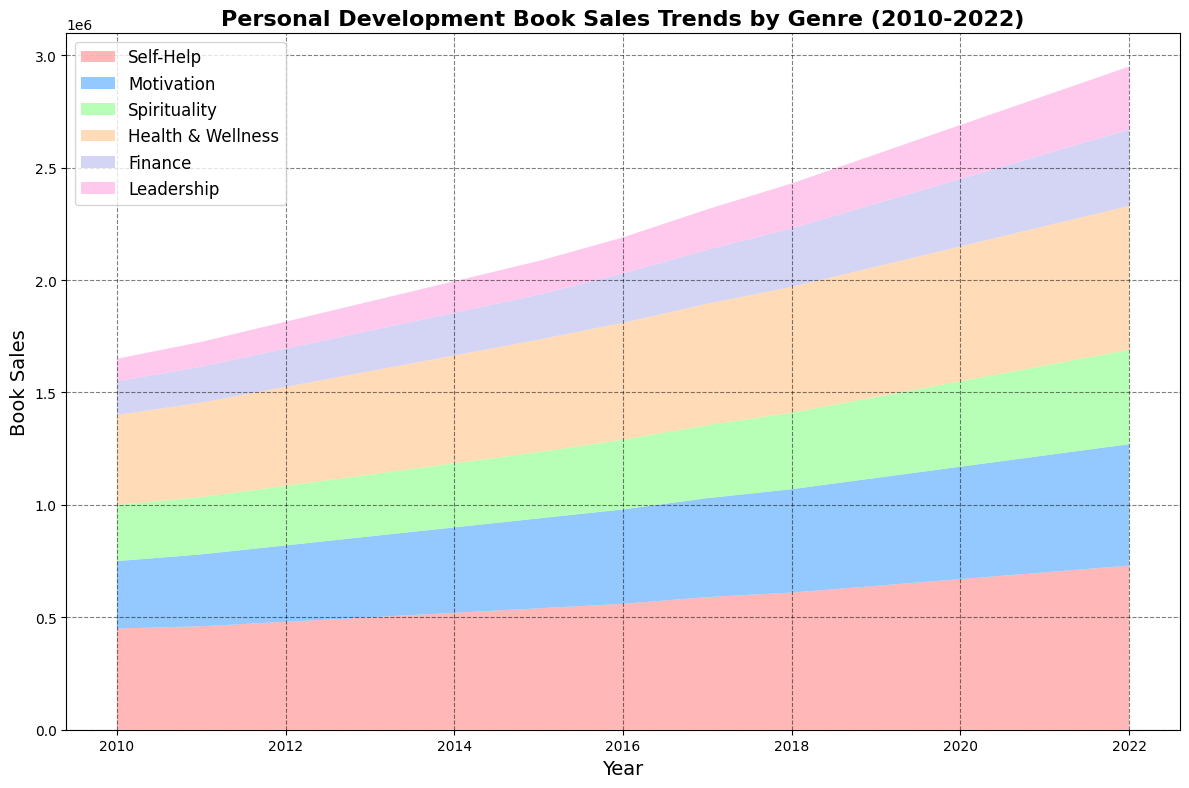what's the total sales for Self-Help books in 2013? In the year 2013, the Self-Help genre reached sales of 500,000 units.
Answer: 500,000 which genre had the highest sales in 2022? By observing the chart, it is evident that the Self-Help genre had the highest sales in the year 2022.
Answer: Self-Help compare the sales trends of Motivation and Leadership genres in 2015. Which one had higher sales? Checking the sales in 2015, the Motivation genre had sales of 400,000 while the Leadership genre had sales of 150,000. Therefore, Motivation had higher sales.
Answer: Motivation in which year did Finance sales reach 260,000 units? Reviewing the chart, Finance sales reached 260,000 units in 2018.
Answer: 2018 how much did Health & Wellness sales increase from 2010 to 2022? In 2010, Health & Wellness sales were 400,000 units, and in 2022 they were 640,000 units. The increase is 640,000 - 400,000 = 240,000 units.
Answer: 240,000 what's the combined sales for Spirituality and Finance genres in 2020? In 2020, Spirituality sales were 380,000 and Finance sales were 300,000. Combined, they add up to 380,000 + 300,000 = 680,000 units.
Answer: 680,000 which year saw Motivation book sales surpass Leadership book sales by the highest margin? The year with the greatest margin is 2022, where Motivation sales were 540,000, and Leadership sales were 280,000. The margin is 540,000 - 280,000 = 260,000 units.
Answer: 2022 what visual color represents the Health & Wellness genre? By observing the area chart, the Health & Wellness genre is depicted in green color.
Answer: green calculate the average sales of Self-Help books from 2010 to 2022. The sum of Self-Help sales from 2010 to 2022 is 450,000 + 460,000 + 480,000 + 500,000 + 520,000 + 540,000 + 560,000 + 590,000 + 610,000 + 640,000 + 670,000 + 700,000 + 730,000 = 7,750,000. The average is 7,750,000 / 13 = 596,154 units (rounded to the nearest whole number).
Answer: 596,154 